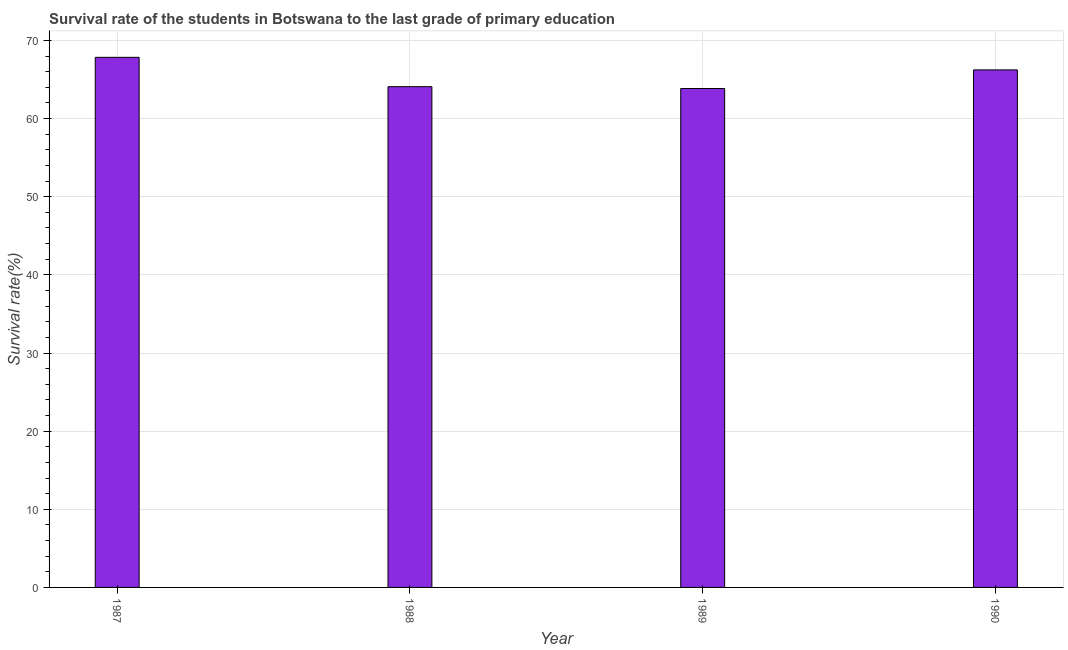Does the graph contain grids?
Make the answer very short. Yes. What is the title of the graph?
Your answer should be compact. Survival rate of the students in Botswana to the last grade of primary education. What is the label or title of the Y-axis?
Your answer should be very brief. Survival rate(%). What is the survival rate in primary education in 1988?
Provide a succinct answer. 64.08. Across all years, what is the maximum survival rate in primary education?
Your response must be concise. 67.84. Across all years, what is the minimum survival rate in primary education?
Provide a succinct answer. 63.85. In which year was the survival rate in primary education maximum?
Make the answer very short. 1987. In which year was the survival rate in primary education minimum?
Make the answer very short. 1989. What is the sum of the survival rate in primary education?
Keep it short and to the point. 262. What is the difference between the survival rate in primary education in 1989 and 1990?
Ensure brevity in your answer.  -2.38. What is the average survival rate in primary education per year?
Your answer should be compact. 65.5. What is the median survival rate in primary education?
Make the answer very short. 65.16. In how many years, is the survival rate in primary education greater than 40 %?
Your answer should be compact. 4. What is the difference between the highest and the second highest survival rate in primary education?
Your response must be concise. 1.61. What is the difference between the highest and the lowest survival rate in primary education?
Offer a terse response. 3.99. In how many years, is the survival rate in primary education greater than the average survival rate in primary education taken over all years?
Provide a succinct answer. 2. Are all the bars in the graph horizontal?
Ensure brevity in your answer.  No. Are the values on the major ticks of Y-axis written in scientific E-notation?
Your response must be concise. No. What is the Survival rate(%) of 1987?
Your response must be concise. 67.84. What is the Survival rate(%) of 1988?
Give a very brief answer. 64.08. What is the Survival rate(%) in 1989?
Provide a short and direct response. 63.85. What is the Survival rate(%) in 1990?
Keep it short and to the point. 66.23. What is the difference between the Survival rate(%) in 1987 and 1988?
Ensure brevity in your answer.  3.76. What is the difference between the Survival rate(%) in 1987 and 1989?
Give a very brief answer. 3.99. What is the difference between the Survival rate(%) in 1987 and 1990?
Make the answer very short. 1.61. What is the difference between the Survival rate(%) in 1988 and 1989?
Your response must be concise. 0.23. What is the difference between the Survival rate(%) in 1988 and 1990?
Your answer should be compact. -2.15. What is the difference between the Survival rate(%) in 1989 and 1990?
Give a very brief answer. -2.38. What is the ratio of the Survival rate(%) in 1987 to that in 1988?
Ensure brevity in your answer.  1.06. What is the ratio of the Survival rate(%) in 1987 to that in 1989?
Your answer should be very brief. 1.06. What is the ratio of the Survival rate(%) in 1987 to that in 1990?
Give a very brief answer. 1.02. What is the ratio of the Survival rate(%) in 1988 to that in 1989?
Provide a short and direct response. 1. What is the ratio of the Survival rate(%) in 1988 to that in 1990?
Make the answer very short. 0.97. What is the ratio of the Survival rate(%) in 1989 to that in 1990?
Ensure brevity in your answer.  0.96. 